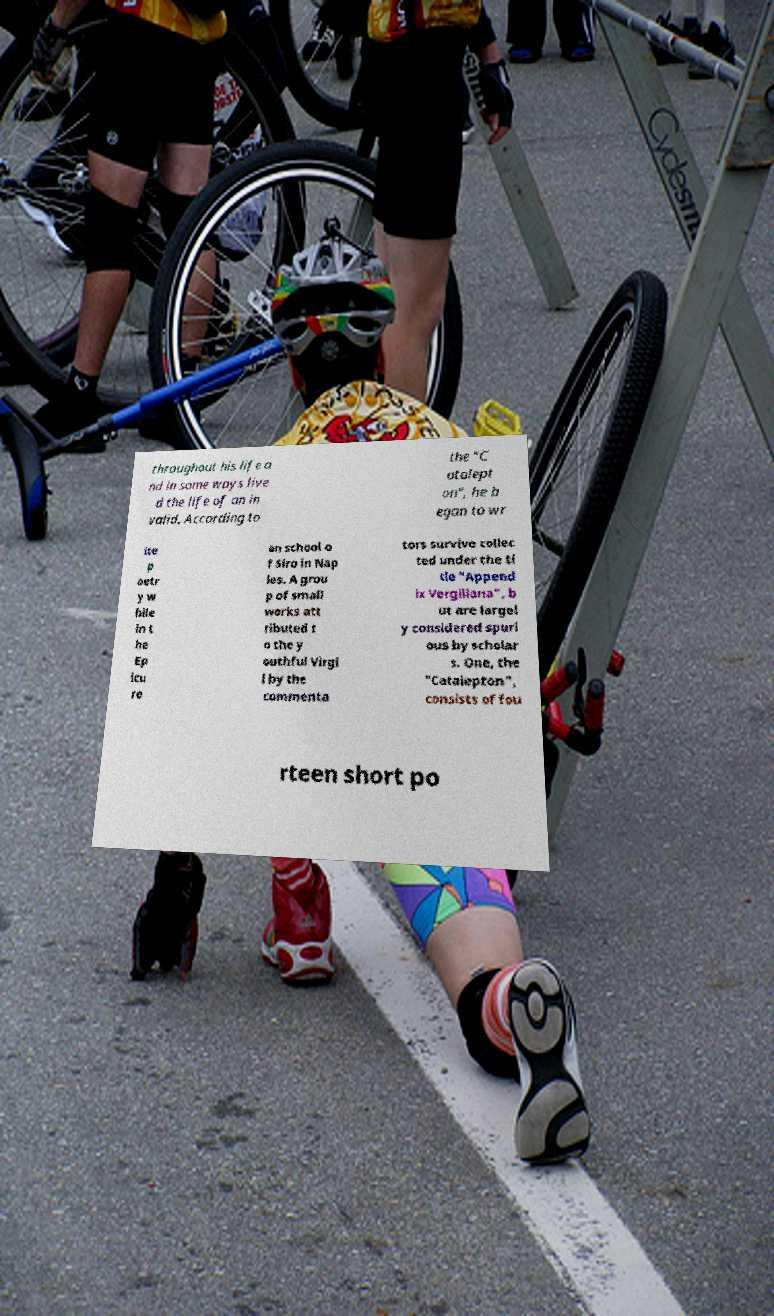Could you extract and type out the text from this image? throughout his life a nd in some ways live d the life of an in valid. According to the "C atalept on", he b egan to wr ite p oetr y w hile in t he Ep icu re an school o f Siro in Nap les. A grou p of small works att ributed t o the y outhful Virgi l by the commenta tors survive collec ted under the ti tle "Append ix Vergiliana", b ut are largel y considered spuri ous by scholar s. One, the "Catalepton", consists of fou rteen short po 